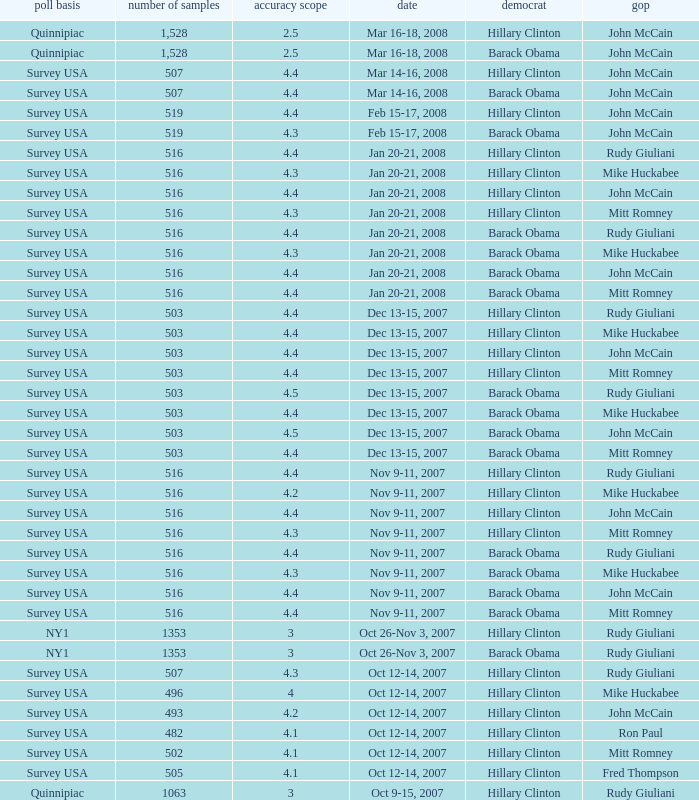What was the date of the poll with a sample size of 496 where Republican Mike Huckabee was chosen? Oct 12-14, 2007. 